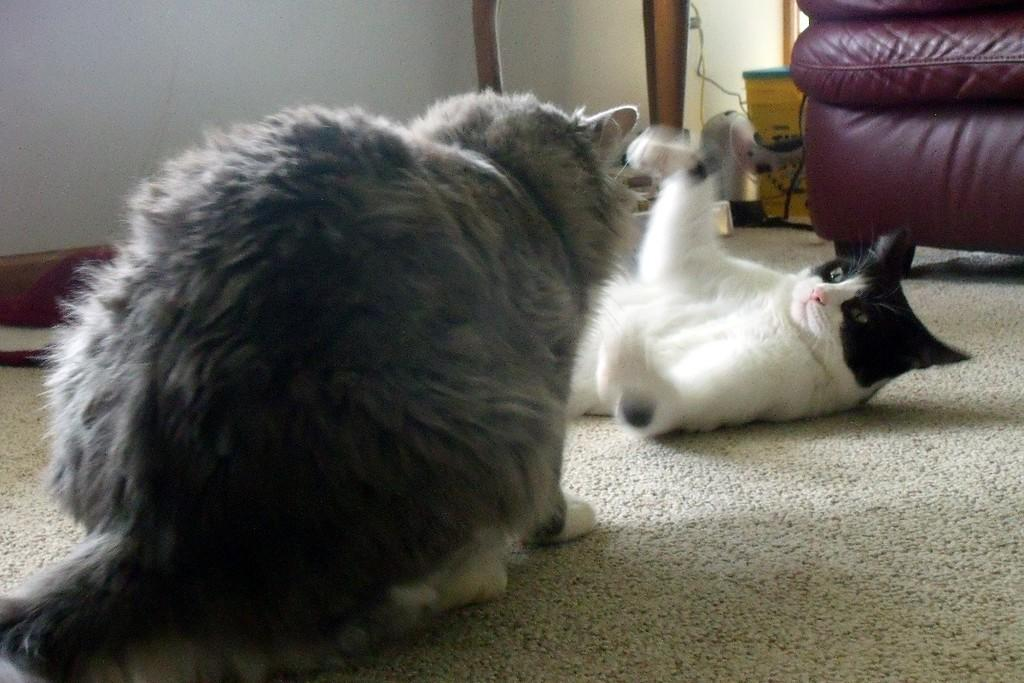How many cats are in the image? There are two cats in the image. What are the cats doing in the image? The cats are looking at each other. What can be seen on the right side of the image? There is a chair on the right side of the image. What is visible in the background of the image? There is a wall in the background of the image. What is present at the bottom of the image? There is a mat in the bottom of the image. What type of sand can be seen in the image? There is no sand present in the image. Is there a hospital visible in the image? No, there is no hospital present in the image. 